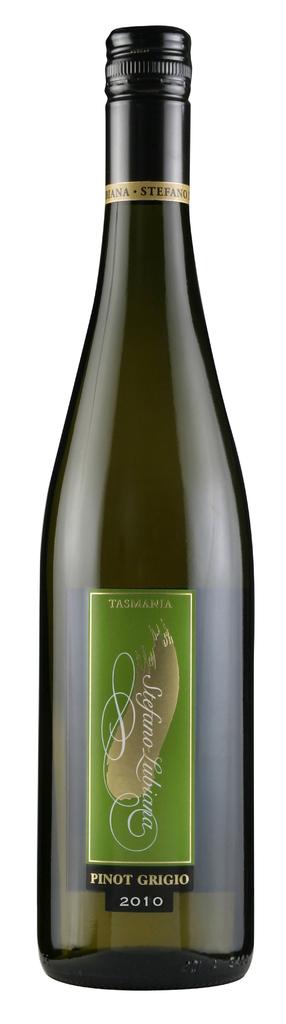What is the year of this drink?
Offer a very short reply. 2010. Is this a pinot?
Offer a very short reply. Yes. 